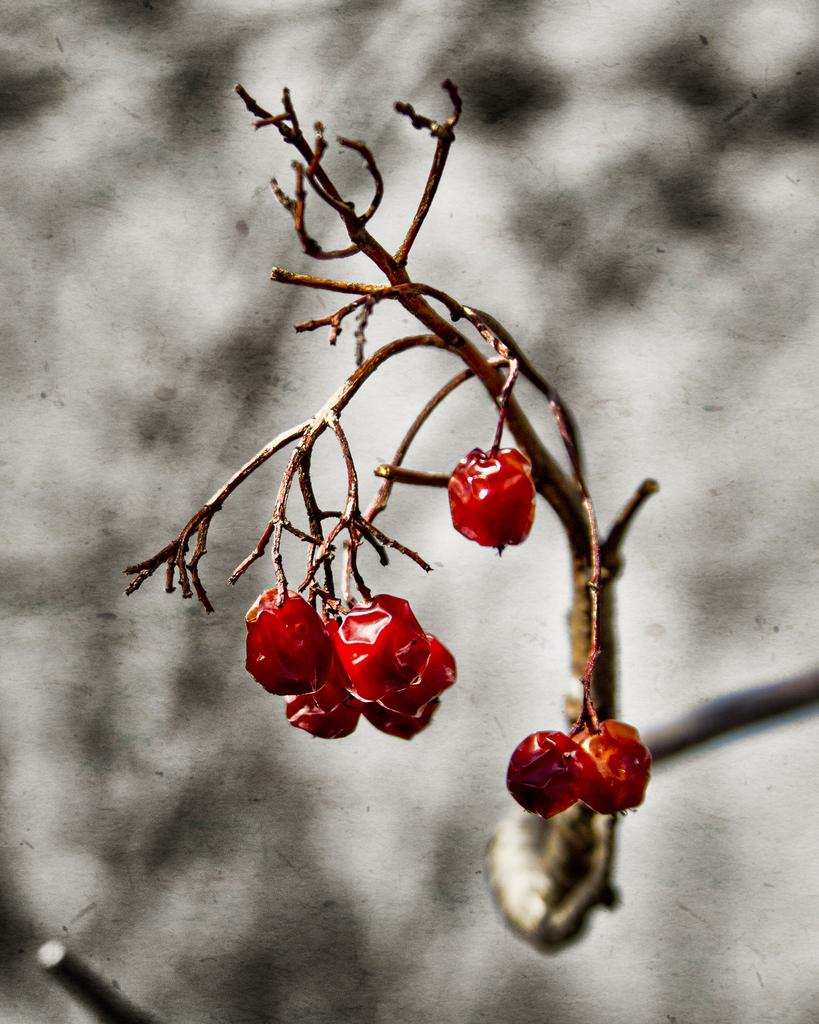What type of fruit is present on the stem of the plant in the image? There are berries on the stem of a plant in the image. What type of agreement is being signed by the beast in the image? There is no beast or agreement present in the image; it only features berries on the stem of a plant. 